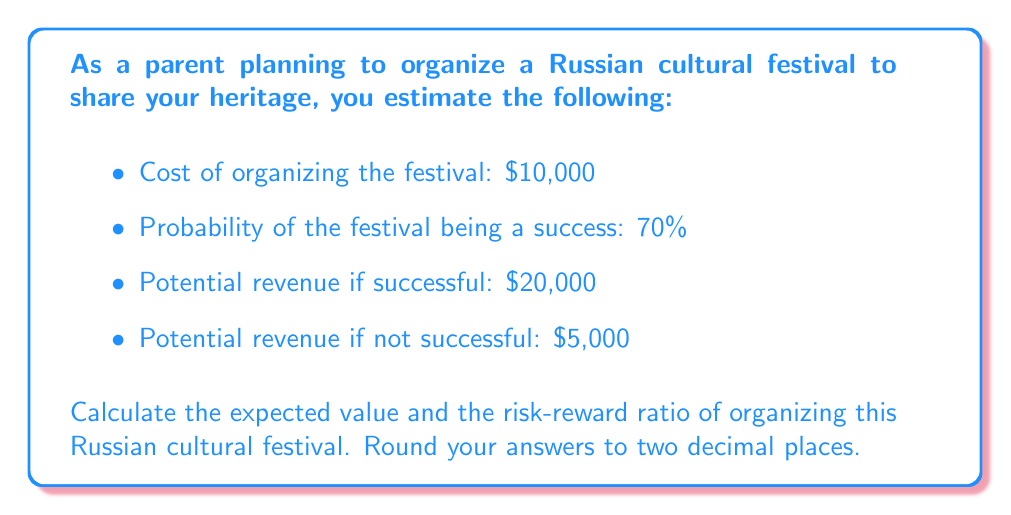Help me with this question. To solve this problem, we'll follow these steps:

1. Calculate the expected value (EV) of organizing the festival
2. Calculate the potential loss
3. Calculate the potential gain
4. Determine the risk-reward ratio

Step 1: Calculate the expected value (EV)

The expected value is the sum of each possible outcome multiplied by its probability.

$$EV = (P_{success} \times R_{success}) + (P_{failure} \times R_{failure}) - C_{organizing}$$

Where:
$P_{success}$ = Probability of success = 70% = 0.7
$P_{failure}$ = Probability of failure = 1 - 0.7 = 0.3
$R_{success}$ = Revenue if successful = $20,000
$R_{failure}$ = Revenue if not successful = $5,000
$C_{organizing}$ = Cost of organizing = $10,000

$$EV = (0.7 \times \$20,000) + (0.3 \times \$5,000) - \$10,000$$
$$EV = \$14,000 + \$1,500 - \$10,000 = \$5,500$$

Step 2: Calculate the potential loss

The potential loss is the difference between the cost of organizing and the revenue if not successful:

$$\text{Potential Loss} = C_{organizing} - R_{failure} = \$10,000 - \$5,000 = \$5,000$$

Step 3: Calculate the potential gain

The potential gain is the difference between the revenue if successful and the cost of organizing:

$$\text{Potential Gain} = R_{success} - C_{organizing} = \$20,000 - \$10,000 = \$10,000$$

Step 4: Determine the risk-reward ratio

The risk-reward ratio is calculated by dividing the potential loss by the potential gain:

$$\text{Risk-Reward Ratio} = \frac{\text{Potential Loss}}{\text{Potential Gain}} = \frac{\$5,000}{\$10,000} = 0.5$$

This means that for every $1 of potential gain, there is $0.50 of potential loss.
Answer: Expected Value: $5,500.00
Risk-Reward Ratio: 0.50 